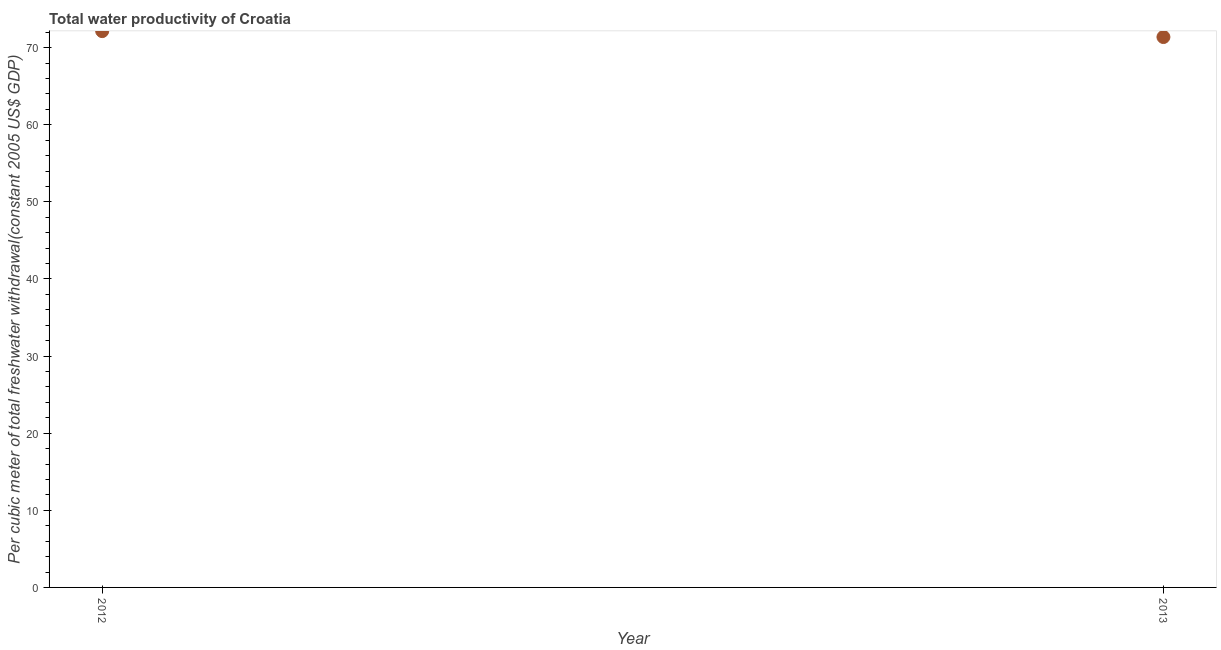What is the total water productivity in 2013?
Keep it short and to the point. 71.37. Across all years, what is the maximum total water productivity?
Provide a short and direct response. 72.14. Across all years, what is the minimum total water productivity?
Offer a terse response. 71.37. What is the sum of the total water productivity?
Give a very brief answer. 143.51. What is the difference between the total water productivity in 2012 and 2013?
Your response must be concise. 0.77. What is the average total water productivity per year?
Your answer should be compact. 71.76. What is the median total water productivity?
Provide a short and direct response. 71.76. What is the ratio of the total water productivity in 2012 to that in 2013?
Your answer should be compact. 1.01. Is the total water productivity in 2012 less than that in 2013?
Offer a very short reply. No. In how many years, is the total water productivity greater than the average total water productivity taken over all years?
Offer a terse response. 1. How many dotlines are there?
Your response must be concise. 1. What is the difference between two consecutive major ticks on the Y-axis?
Ensure brevity in your answer.  10. Does the graph contain any zero values?
Your answer should be compact. No. Does the graph contain grids?
Offer a very short reply. No. What is the title of the graph?
Ensure brevity in your answer.  Total water productivity of Croatia. What is the label or title of the Y-axis?
Make the answer very short. Per cubic meter of total freshwater withdrawal(constant 2005 US$ GDP). What is the Per cubic meter of total freshwater withdrawal(constant 2005 US$ GDP) in 2012?
Offer a very short reply. 72.14. What is the Per cubic meter of total freshwater withdrawal(constant 2005 US$ GDP) in 2013?
Keep it short and to the point. 71.37. What is the difference between the Per cubic meter of total freshwater withdrawal(constant 2005 US$ GDP) in 2012 and 2013?
Keep it short and to the point. 0.77. 